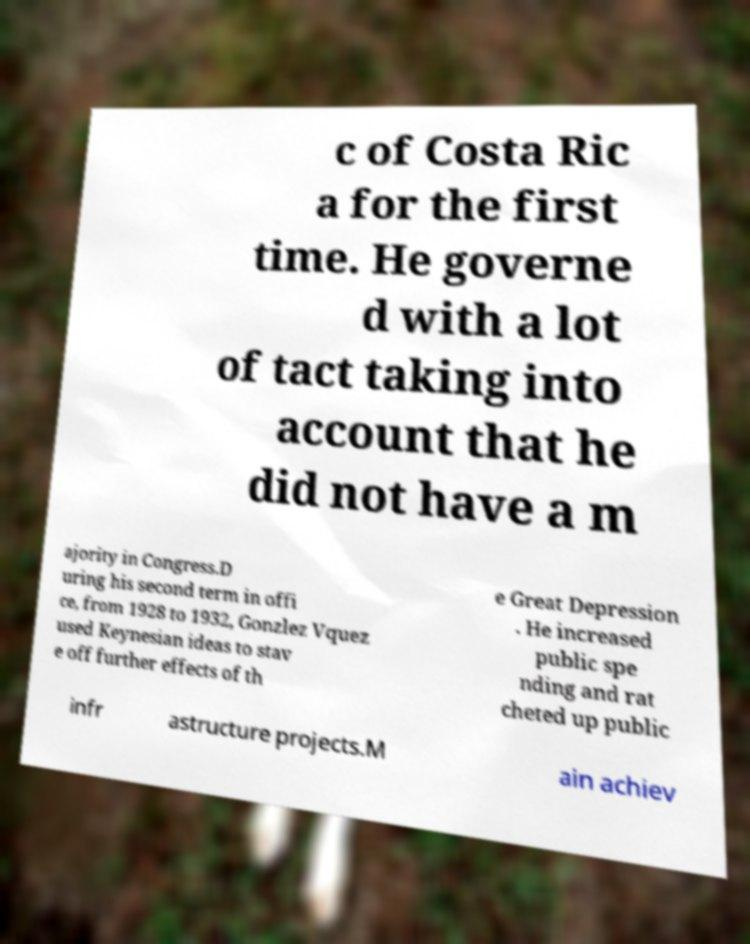Could you extract and type out the text from this image? c of Costa Ric a for the first time. He governe d with a lot of tact taking into account that he did not have a m ajority in Congress.D uring his second term in offi ce, from 1928 to 1932, Gonzlez Vquez used Keynesian ideas to stav e off further effects of th e Great Depression . He increased public spe nding and rat cheted up public infr astructure projects.M ain achiev 